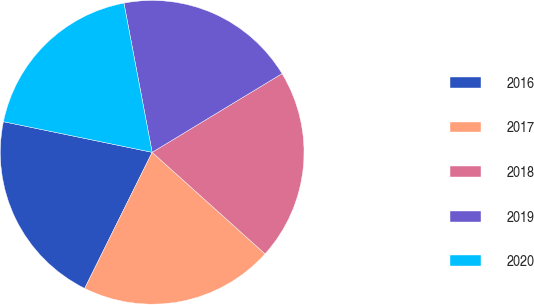Convert chart. <chart><loc_0><loc_0><loc_500><loc_500><pie_chart><fcel>2016<fcel>2017<fcel>2018<fcel>2019<fcel>2020<nl><fcel>20.91%<fcel>20.67%<fcel>20.33%<fcel>19.31%<fcel>18.79%<nl></chart> 